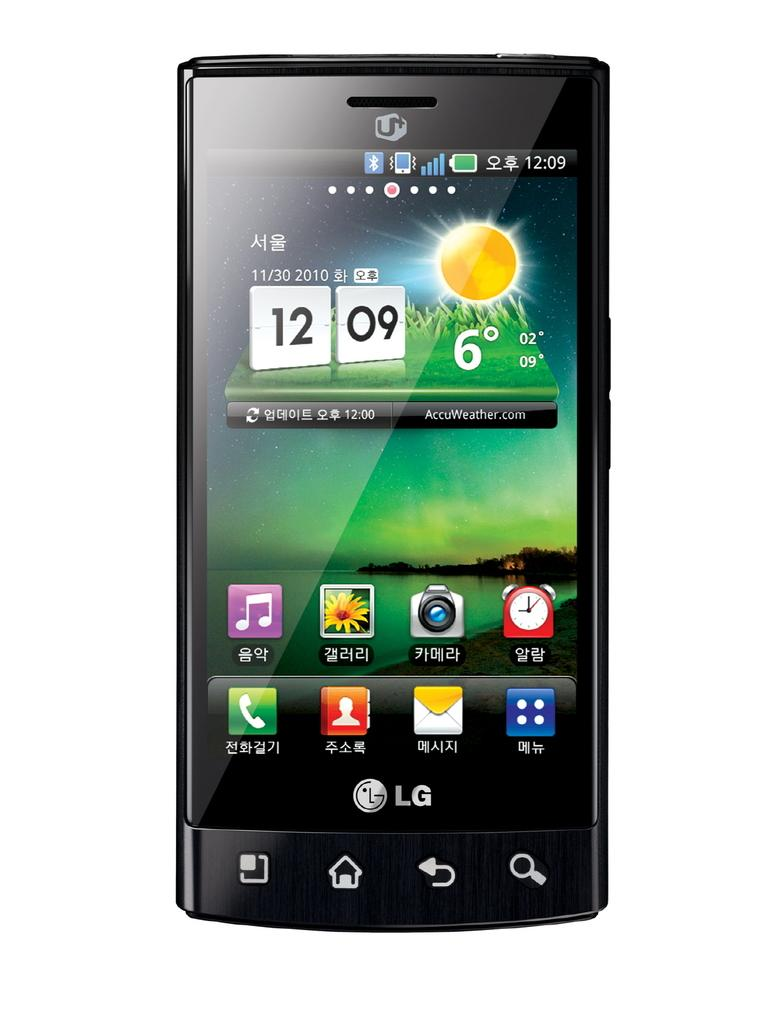<image>
Relay a brief, clear account of the picture shown. The cell phone is a model from the LG company. 